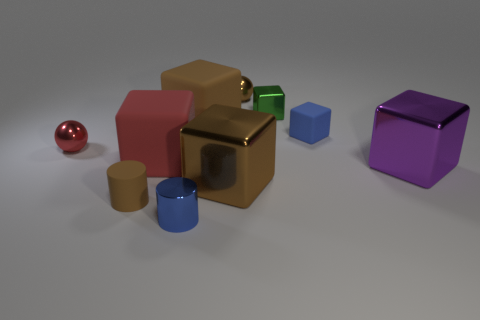Can you tell me which objects in the image are spheres? Certainly, based on the image, there is one object that is a sphere, which is red in color. 